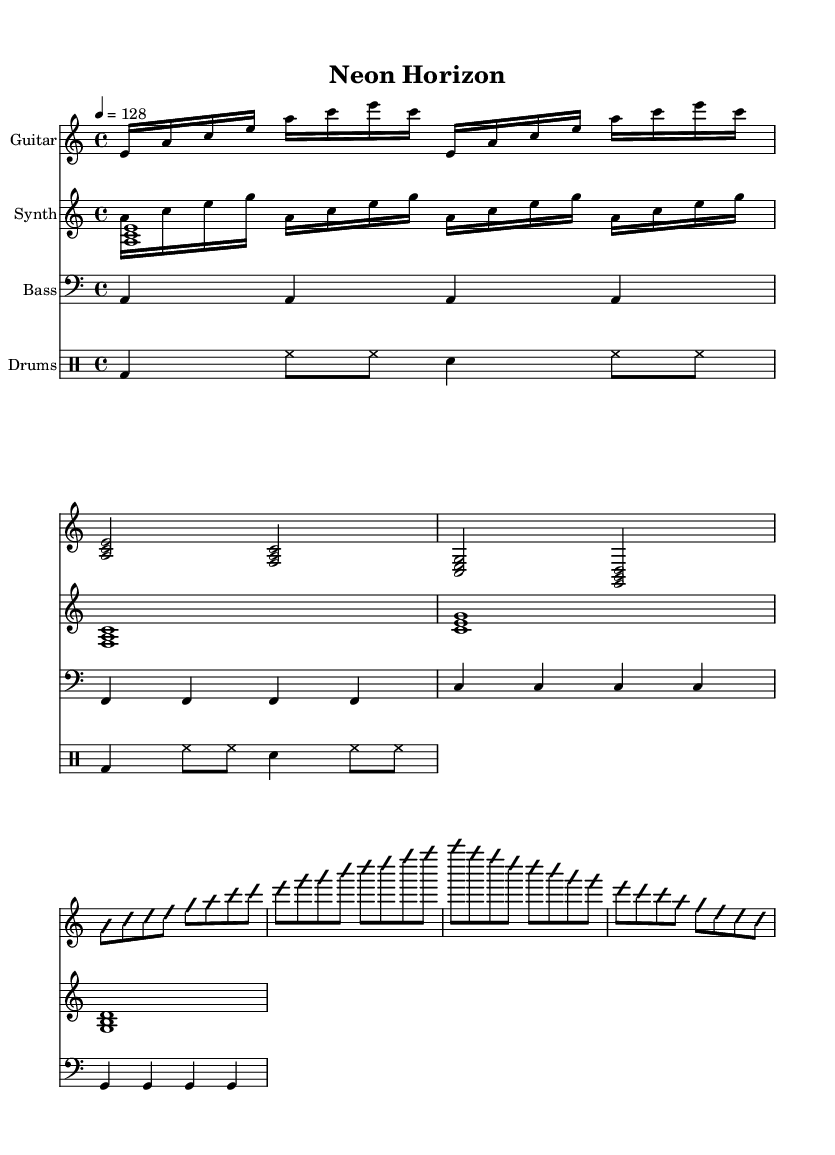What is the key signature of this music? The key signature is A minor, which is indicated by having no sharps or flats. This can be identified on the staff at the beginning of the piece.
Answer: A minor What is the time signature of this piece? The time signature is 4/4, which is shown at the beginning of the sheet music. It signifies that there are four beats in each measure and the quarter note gets one beat.
Answer: 4/4 What is the tempo marking for this piece? The tempo marking is 128 beats per minute, which sets a lively pace for the piece. It is indicated in standard tempo notation above the staff.
Answer: 128 How many measures are in the guitar breakdown section? The guitar breakdown section consists of 4 measures, as there are 4 sets of beats (2 beats per chord) indicated in the notation of that section.
Answer: 4 How many times is the guitar intro repeated? The guitar intro is repeated twice, as shown by the repeat sign that indicates that the section should play through again.
Answer: 2 What is the character of the guitar solo in this piece? The guitar solo is characterized by improvisation, noted with the instruction "improvisationOn" and "improvisationOff," signaling freedom in note selection within the played rhythm.
Answer: Improvisational What is the overall thematic material of the synth voices? The synth voices create a harmonious pad with rhythmic arpeggios, giving a layered texture that complements the main elements of the piece, indicated by their respective note patterns.
Answer: Harmonic pad and arpeggio 